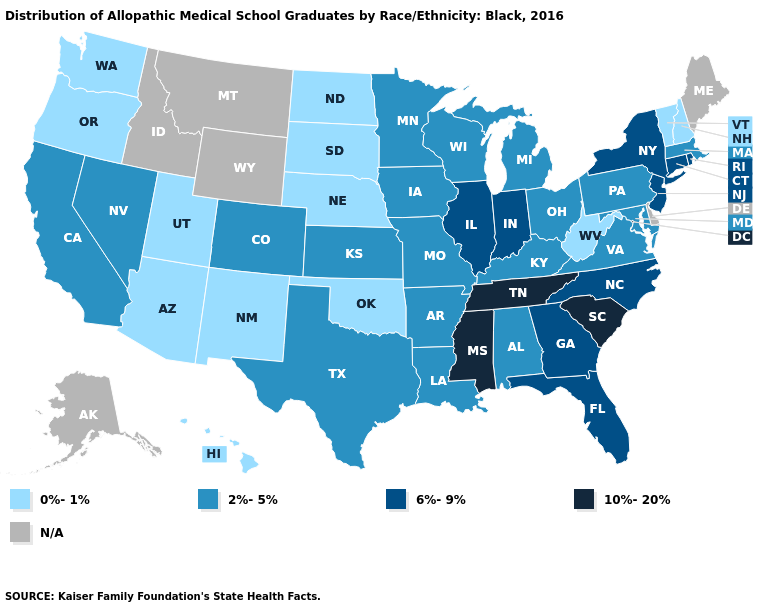Among the states that border Missouri , does Iowa have the highest value?
Give a very brief answer. No. Does the first symbol in the legend represent the smallest category?
Short answer required. Yes. Which states hav the highest value in the MidWest?
Concise answer only. Illinois, Indiana. Name the states that have a value in the range 6%-9%?
Give a very brief answer. Connecticut, Florida, Georgia, Illinois, Indiana, New Jersey, New York, North Carolina, Rhode Island. Name the states that have a value in the range 2%-5%?
Short answer required. Alabama, Arkansas, California, Colorado, Iowa, Kansas, Kentucky, Louisiana, Maryland, Massachusetts, Michigan, Minnesota, Missouri, Nevada, Ohio, Pennsylvania, Texas, Virginia, Wisconsin. Name the states that have a value in the range 2%-5%?
Quick response, please. Alabama, Arkansas, California, Colorado, Iowa, Kansas, Kentucky, Louisiana, Maryland, Massachusetts, Michigan, Minnesota, Missouri, Nevada, Ohio, Pennsylvania, Texas, Virginia, Wisconsin. What is the value of Georgia?
Short answer required. 6%-9%. What is the lowest value in states that border Vermont?
Answer briefly. 0%-1%. What is the value of Kansas?
Answer briefly. 2%-5%. Does the map have missing data?
Quick response, please. Yes. What is the highest value in states that border North Dakota?
Keep it brief. 2%-5%. Name the states that have a value in the range 6%-9%?
Give a very brief answer. Connecticut, Florida, Georgia, Illinois, Indiana, New Jersey, New York, North Carolina, Rhode Island. Among the states that border Indiana , does Illinois have the highest value?
Concise answer only. Yes. What is the lowest value in the Northeast?
Be succinct. 0%-1%. 